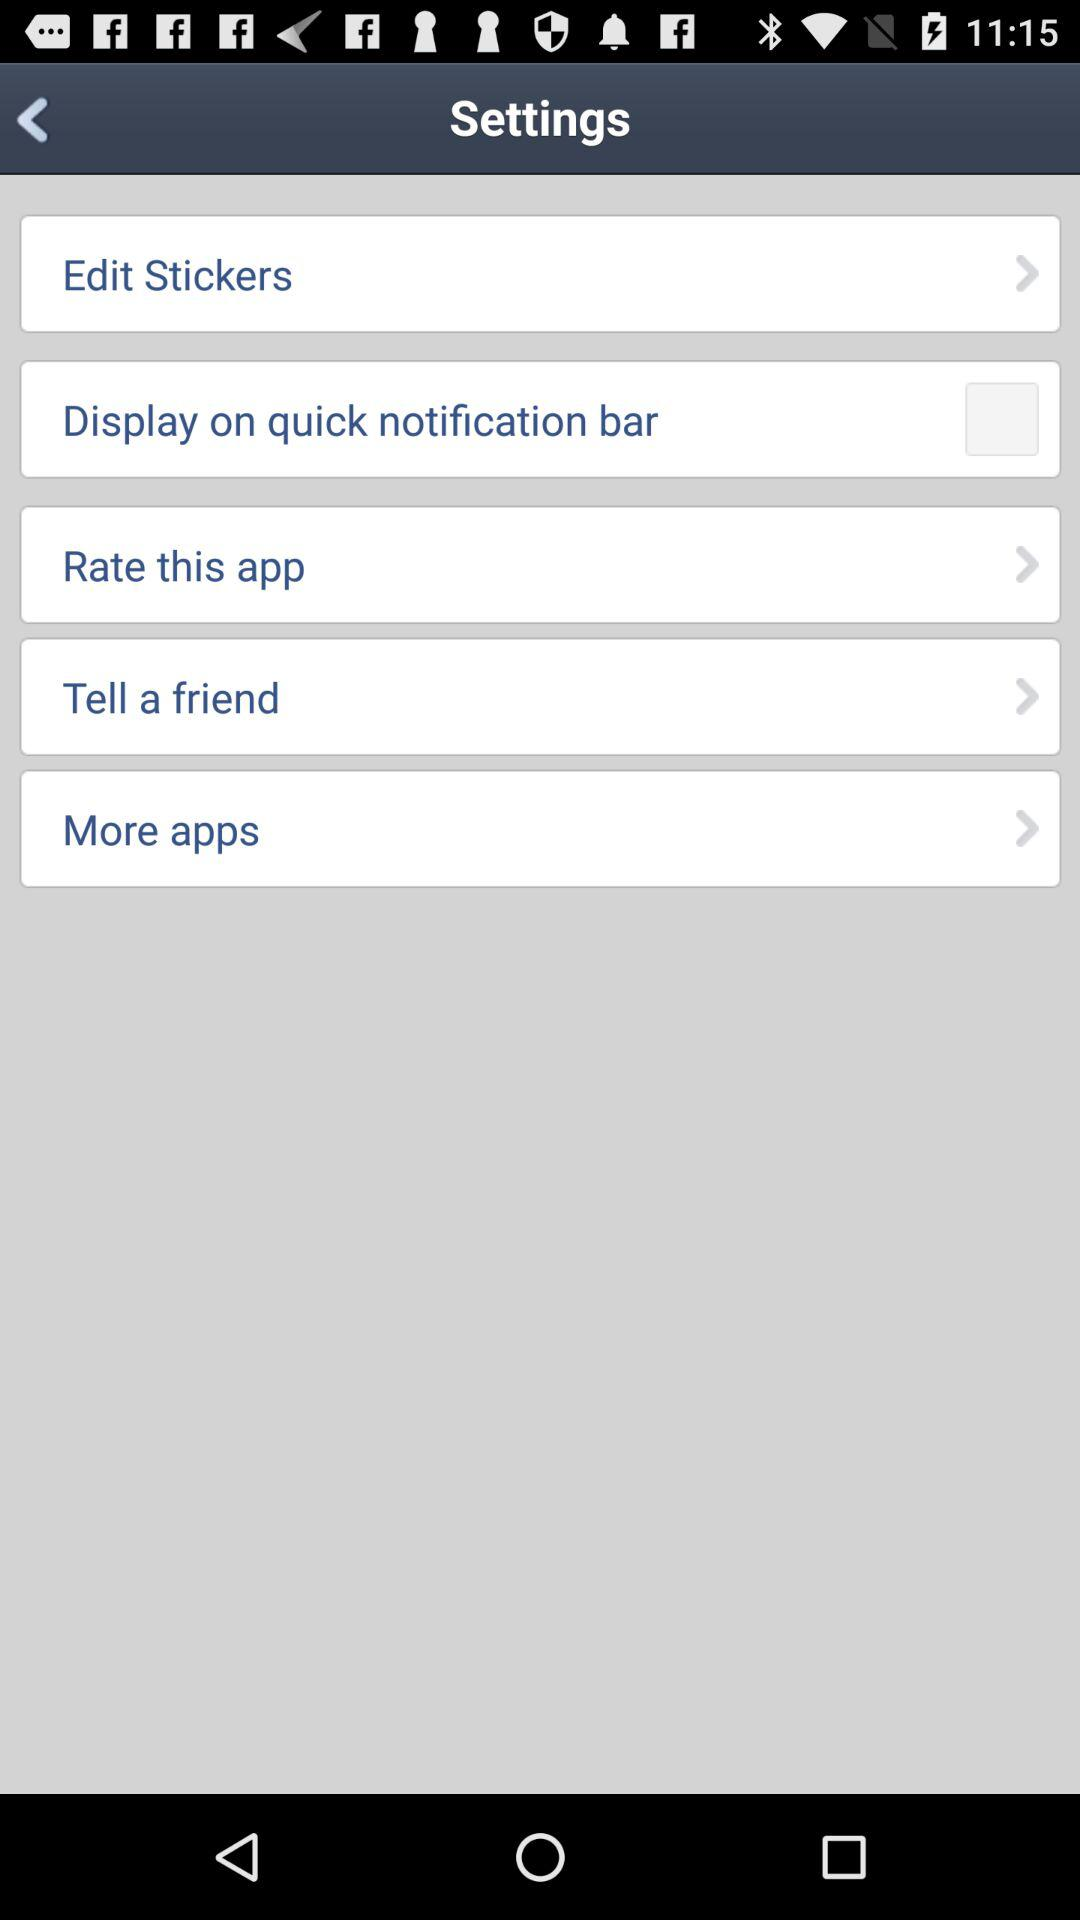What is the status of "Display on the quick notification bar"? The status is "off". 